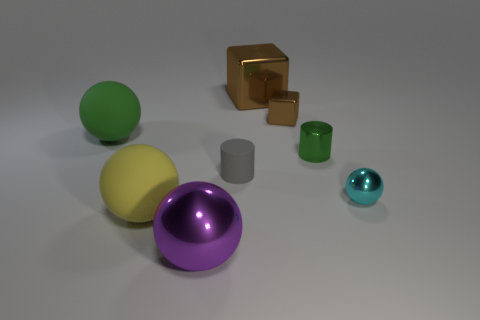Is there anything else that has the same material as the tiny gray object?
Provide a short and direct response. Yes. What size is the cyan object that is the same shape as the large yellow object?
Keep it short and to the point. Small. Is the number of large yellow rubber balls that are left of the gray thing greater than the number of big purple metallic balls?
Your response must be concise. No. Are the green object on the left side of the purple metallic sphere and the big purple ball made of the same material?
Your answer should be very brief. No. What is the size of the green object to the left of the sphere that is in front of the matte ball in front of the cyan object?
Your answer should be compact. Large. There is a ball that is made of the same material as the big purple object; what size is it?
Your response must be concise. Small. There is a large object that is both right of the large yellow matte object and in front of the large green thing; what is its color?
Provide a short and direct response. Purple. There is a big matte thing in front of the large green sphere; is its shape the same as the green thing right of the large shiny ball?
Provide a short and direct response. No. What is the material of the small cylinder to the right of the big brown block?
Ensure brevity in your answer.  Metal. There is a sphere that is the same color as the tiny shiny cylinder; what is its size?
Give a very brief answer. Large. 